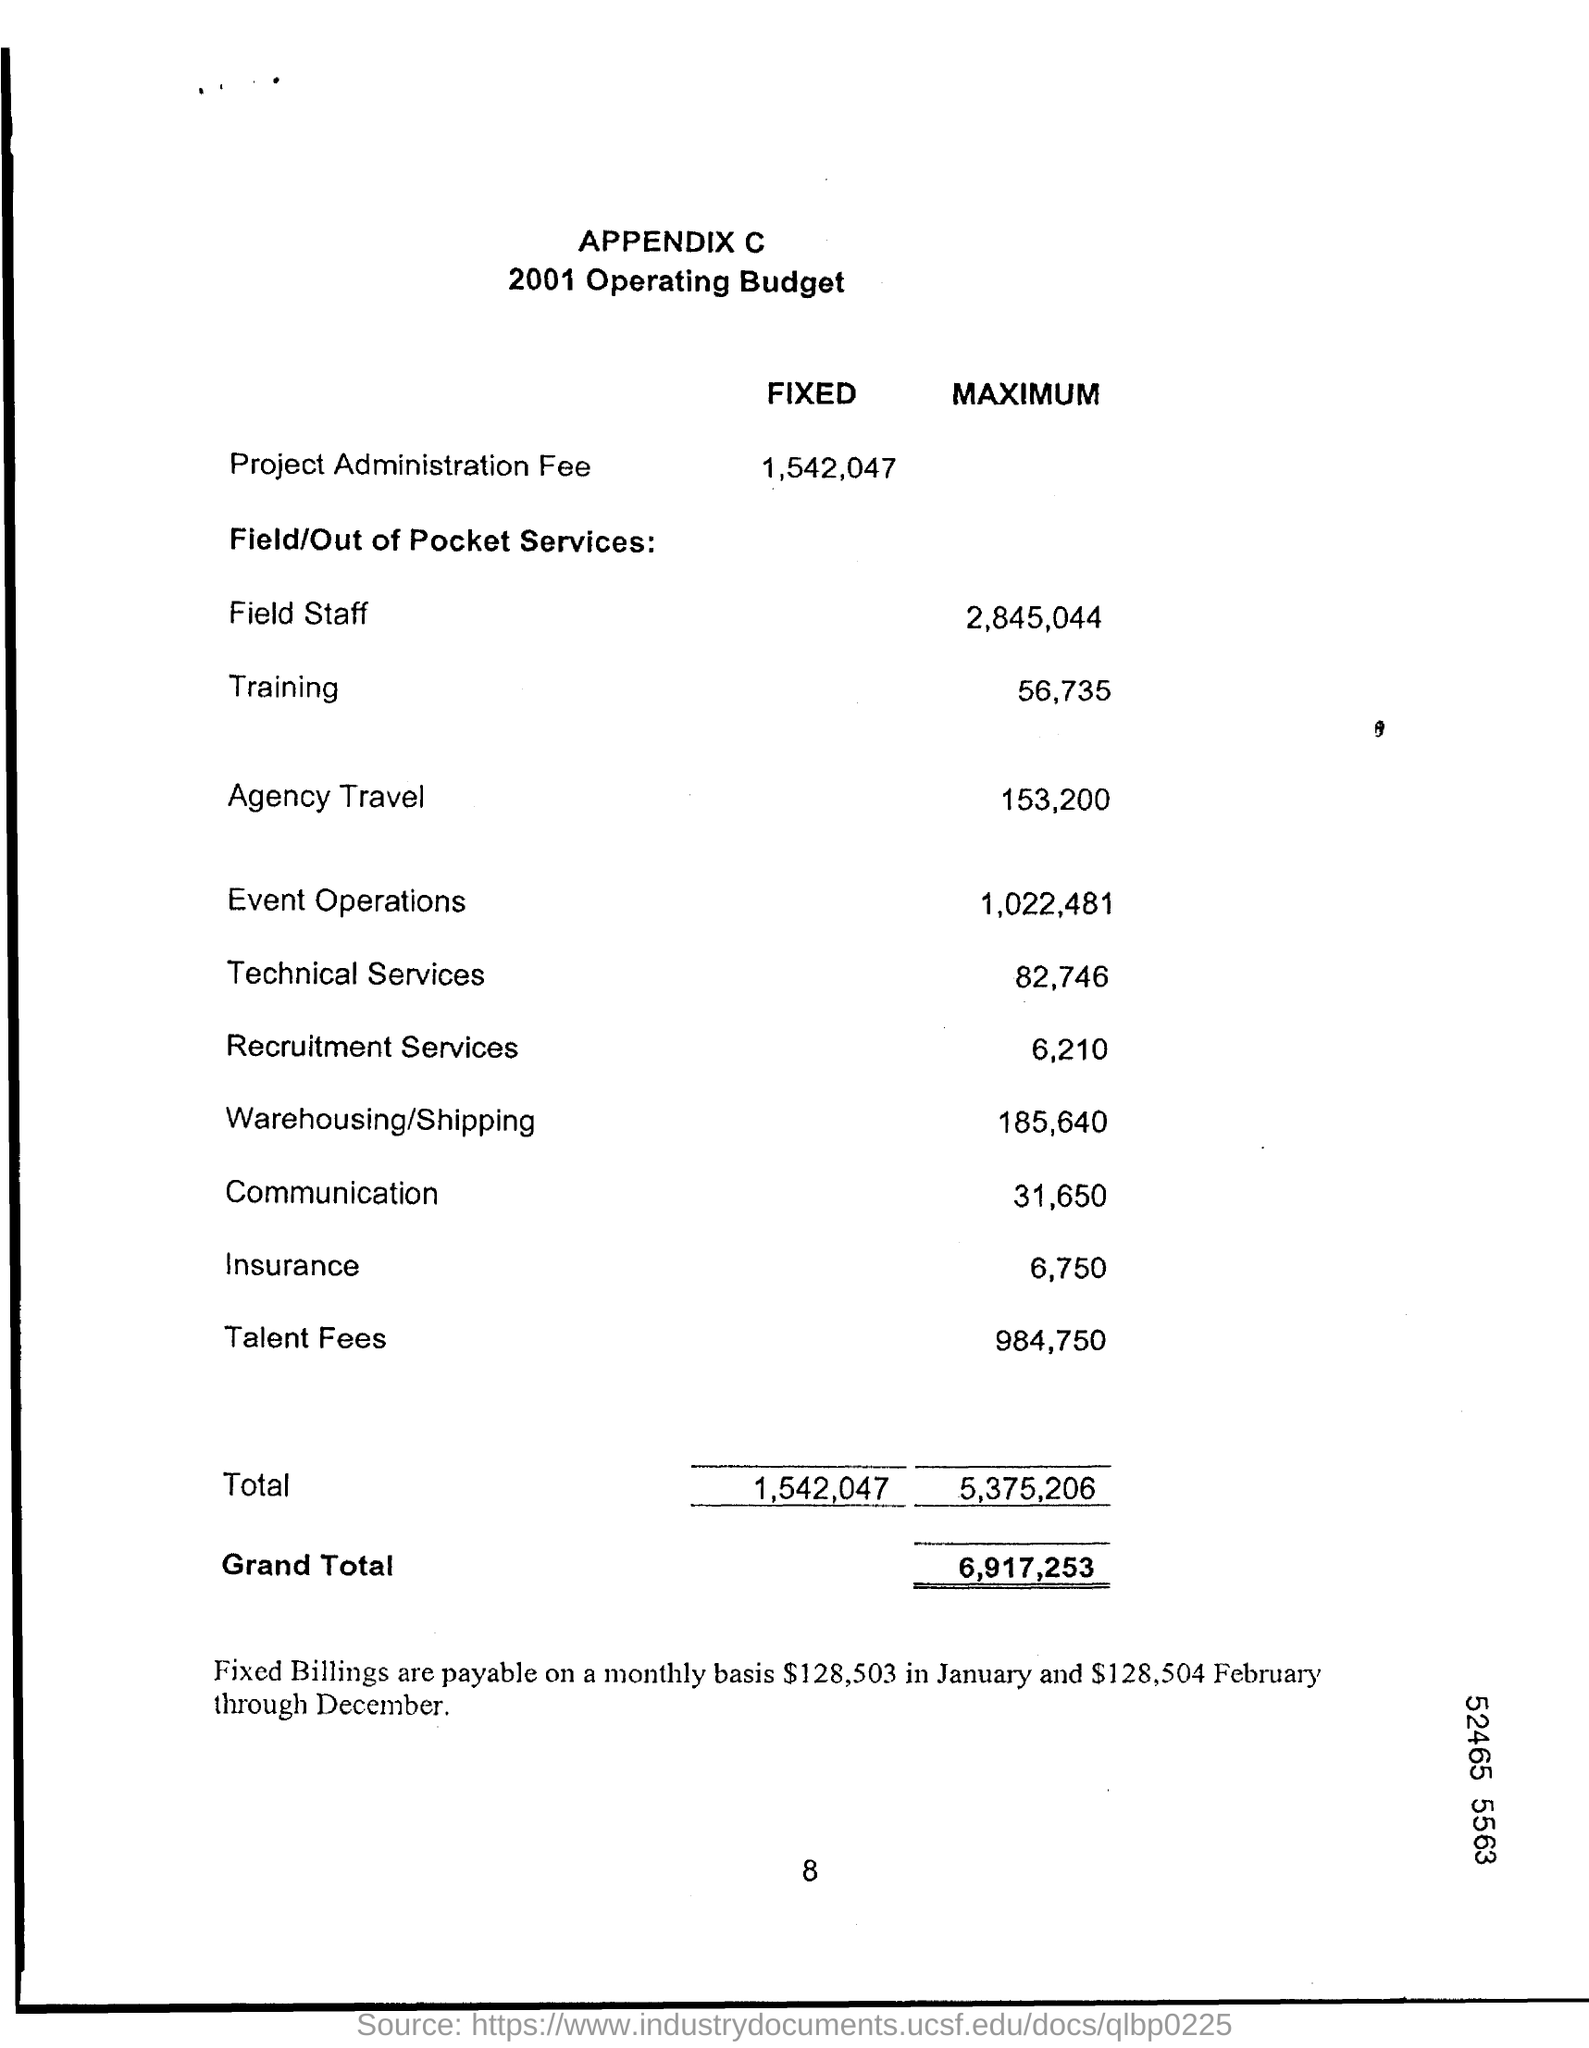List a handful of essential elements in this visual. The maximum budget for insurance is 6,750. The maximum budget for field staff is 2,845,044. The fixed budget for Project Administration Fee is 1,542,047. The maximum budget allocated for communication is 31,650. 